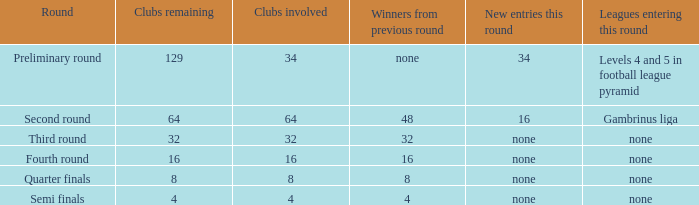Identify the fewest clubs left 4.0. 